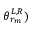Convert formula to latex. <formula><loc_0><loc_0><loc_500><loc_500>\theta _ { r _ { m } } ^ { L , R } )</formula> 